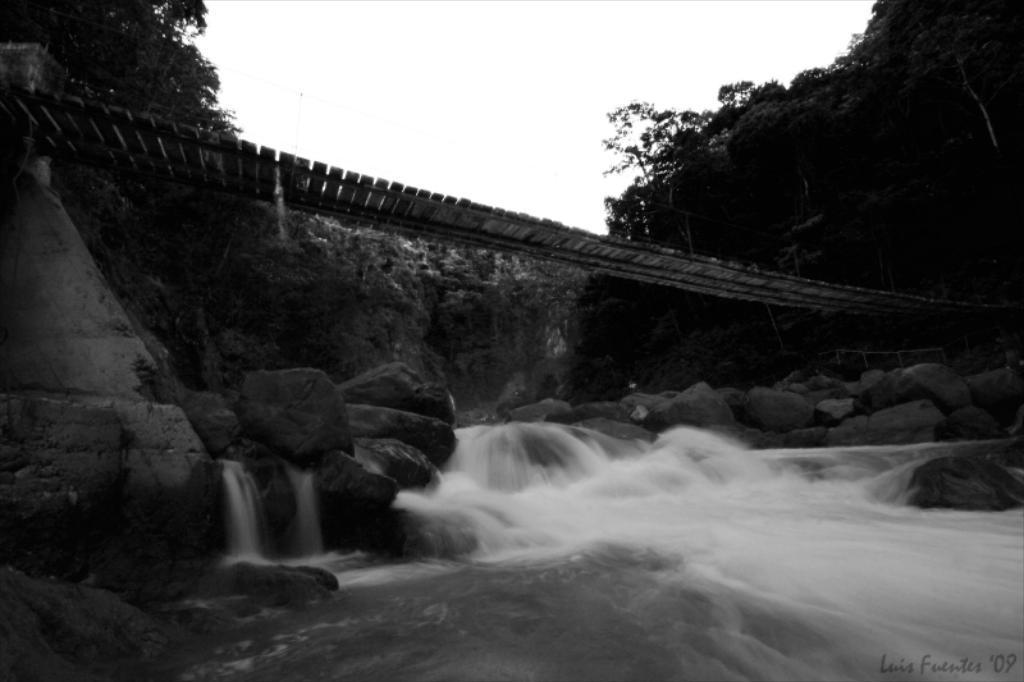Please provide a concise description of this image. In the center of the image we can see wooden bridge. In the background there is a sky, trees. At the bottom of the image we can see rocks and water. 